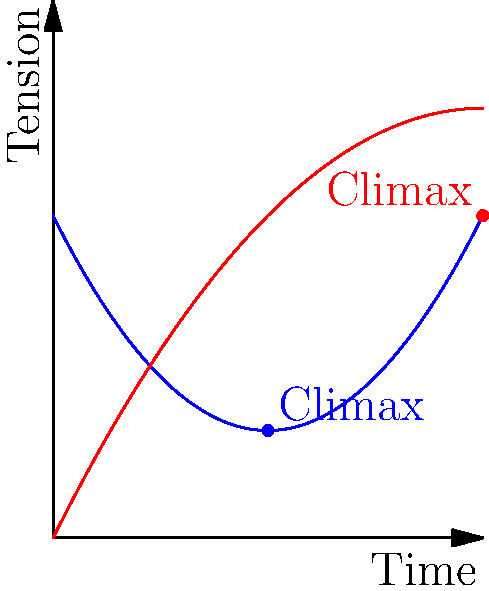Analyze the tension curves of an AI-driven story arc (blue) versus a traditional story arc (red) in the graph. How does the AI-driven arc's pacing differ from the traditional arc, and what implications might this have for player engagement? To evaluate the pacing of the AI-driven story arc compared to the traditional arc:

1. Shape analysis:
   - AI-driven arc (blue): Parabolic shape, concave up
   - Traditional arc (red): Parabolic shape, concave down

2. Tension progression:
   - AI-driven arc: Starts high, dips, then rises sharply
   - Traditional arc: Steadily increases, then tapers off

3. Climax positioning:
   - AI-driven arc: Earlier (around 50% of the timeline)
   - Traditional arc: Later (near the end of the timeline)

4. Rate of change:
   - AI-driven arc: Rapid changes in tension
   - Traditional arc: More gradual, consistent increase

5. Implications for player engagement:
   - AI-driven arc may create a more unpredictable experience
   - Early climax in AI arc could lead to a longer denouement
   - Rapid tension changes in AI arc might be more exciting but potentially disorienting
   - Traditional arc offers a familiar, steady build-up that players may find more comfortable

6. Adaptability:
   - AI-driven arc suggests potential for dynamic adjustment based on player actions
   - Traditional arc represents a more fixed, pre-determined narrative structure

The AI-driven arc demonstrates a non-traditional approach to storytelling, potentially offering a more dynamic and responsive narrative experience tailored to individual player interactions and preferences.
Answer: The AI-driven arc shows earlier climax, rapid tension changes, and potential for dynamic adjustment, likely leading to a more unpredictable and personalized player experience compared to the traditional arc's steady build-up. 